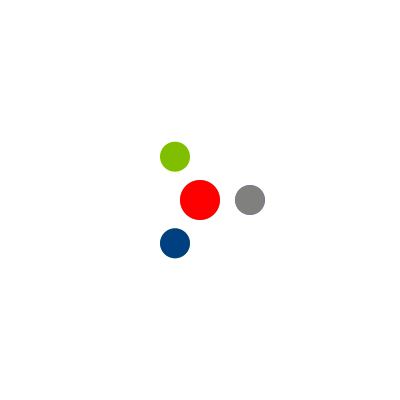In a molecular structure visualization, a tetrahedral molecule is shown before and after rotation. The original structure is represented by solid colors, while the rotated structure is shown with transparent colors. What is the angle of rotation applied to the molecule? To determine the angle of rotation, we need to follow these steps:

1. Identify the initial positions of the atoms:
   - Red (center): (0, 0)
   - Blue: (50, 0)
   - Green: (-25, 43.3)
   - Yellow: (-25, -43.3)

2. Observe the final positions after rotation:
   - Blue atom moves to the position previously occupied by the Green atom
   - Green atom moves to the position previously occupied by the Yellow atom
   - Yellow atom moves to the position previously occupied by the Blue atom

3. Recognize the rotational symmetry:
   - The molecule has tetrahedral symmetry with three-fold rotational axes
   - A complete rotation around a three-fold axis is 360°

4. Calculate the rotation angle:
   - Each step in the three-fold rotation is 360° / 3 = 120°
   - The observed rotation matches one step of this three-fold rotation

Therefore, the angle of rotation applied to the molecule is 120°.
Answer: 120° 